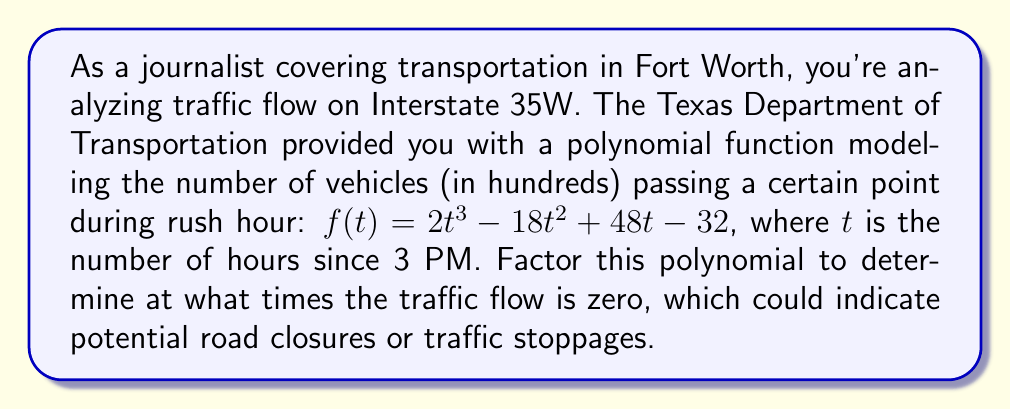Give your solution to this math problem. To solve this problem, we need to factor the polynomial $f(t) = 2t^3 - 18t^2 + 48t - 32$. We'll follow these steps:

1) First, let's check if there's a common factor:
   $2t^3 - 18t^2 + 48t - 32 = 2(t^3 - 9t^2 + 24t - 16)$

2) Now, we'll try to guess one root. By the rational root theorem, possible roots are factors of 16: ±1, ±2, ±4, ±8, ±16. 
   Testing these, we find that $t = 2$ is a root.

3) So, $(t - 2)$ is a factor. We can divide the polynomial by $(t - 2)$:

   $$\frac{t^3 - 9t^2 + 24t - 16}{t - 2} = t^2 - 7t + 8$$

4) The quadratic $t^2 - 7t + 8$ can be factored further:
   $t^2 - 7t + 8 = (t - 4)(t - 3)$

5) Putting it all together:

   $2t^3 - 18t^2 + 48t - 32 = 2(t - 2)(t - 3)(t - 4)$

Therefore, the traffic flow is zero when $t = 2$, $t = 3$, or $t = 4$, corresponding to 5 PM, 6 PM, and 7 PM respectively.
Answer: $f(t) = 2(t - 2)(t - 3)(t - 4)$
Traffic flow is zero at 5 PM, 6 PM, and 7 PM. 